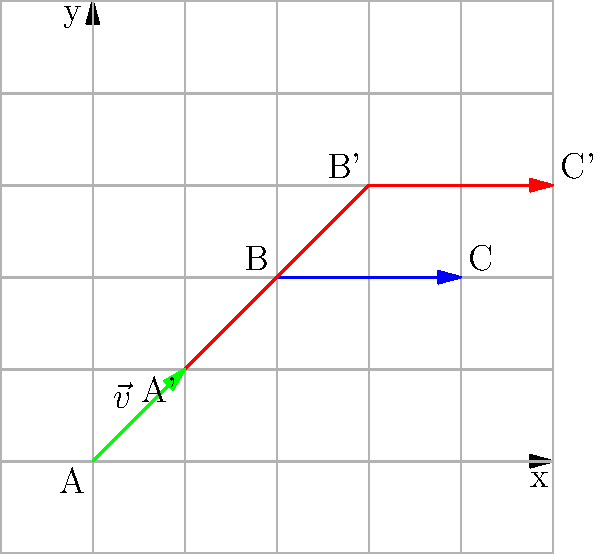In a growing metropolitan area, urban planners are studying traffic flow patterns. The blue arrow represents the current main traffic route from point A to C via B. Due to population growth and urban expansion, this route needs to be translated by vector $\vec{v} = \langle 2, 2 \rangle$. The resulting new route is shown in red. If the coordinates of point B on the original route are (4, 4), what are the coordinates of point B' on the new route? To solve this problem, we need to apply the concept of translation in transformational geometry. Here's a step-by-step explanation:

1. Understand the given information:
   - The original point B has coordinates (4, 4)
   - The translation vector $\vec{v}$ is $\langle 2, 2 \rangle$

2. Recall the formula for translation:
   If a point $(x, y)$ is translated by a vector $\langle a, b \rangle$, the new coordinates are $(x + a, y + b)$

3. Apply the translation to point B:
   - Original B: (4, 4)
   - Translation vector: $\langle 2, 2 \rangle$
   - New B' coordinates: $(4 + 2, 4 + 2)$

4. Calculate the result:
   B' coordinates = $(6, 6)$

Therefore, the coordinates of point B' on the new route are (6, 6).
Answer: (6, 6) 